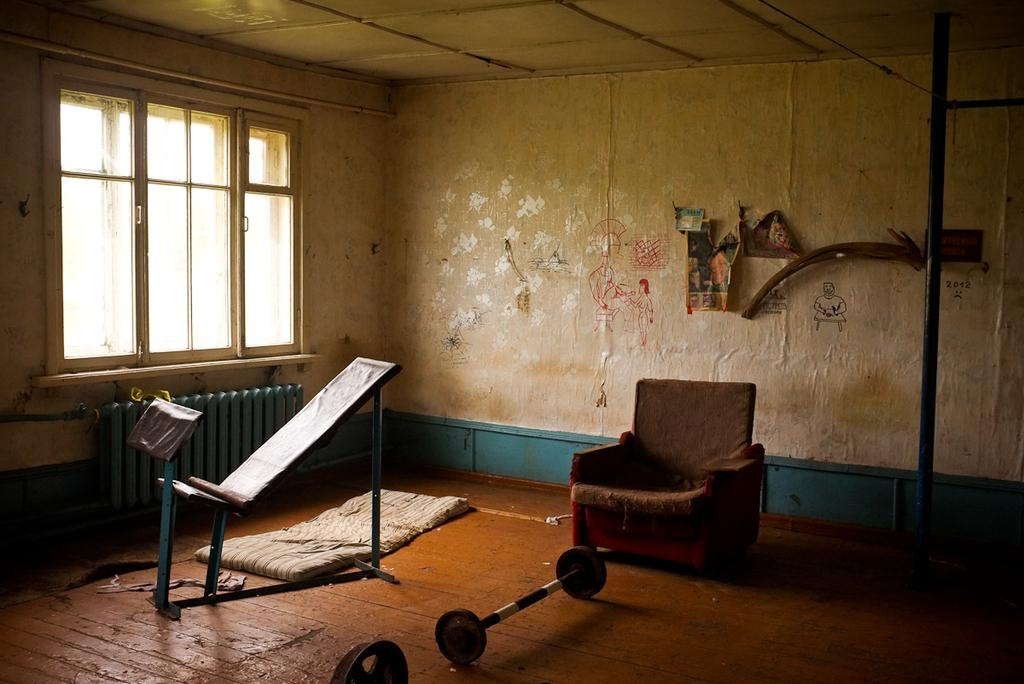What type of structure can be seen in the image? There is a wall in the image. What feature is present in the wall? There is a window in the image. What type of furniture is visible in the image? There is a sofa in the image. What type of sleeping arrangement is on the floor in the image? There is a bed on the floor in the image. What language is spoken by the stars visible through the window in the image? There are no stars visible through the window in the image, and therefore no language can be attributed to them. 